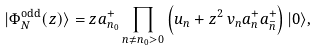<formula> <loc_0><loc_0><loc_500><loc_500>| \Phi ^ { \text {odd} } _ { N } ( z ) \rangle = z a _ { n _ { 0 } } ^ { + } \prod _ { n \neq { n _ { 0 } } > 0 } \left ( u _ { n } + z ^ { 2 } \, v _ { n } { a } _ { n } ^ { + } { a } _ { \bar { n } } ^ { + } \right ) | 0 \rangle ,</formula> 